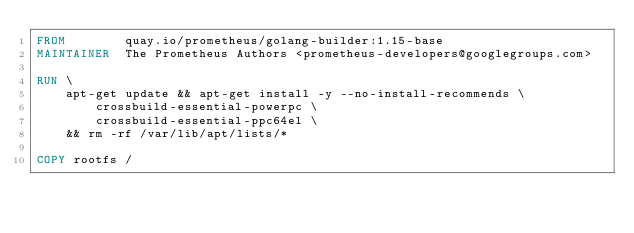Convert code to text. <code><loc_0><loc_0><loc_500><loc_500><_Dockerfile_>FROM        quay.io/prometheus/golang-builder:1.15-base
MAINTAINER  The Prometheus Authors <prometheus-developers@googlegroups.com>

RUN \
    apt-get update && apt-get install -y --no-install-recommends \
        crossbuild-essential-powerpc \
        crossbuild-essential-ppc64el \
    && rm -rf /var/lib/apt/lists/*

COPY rootfs /
</code> 